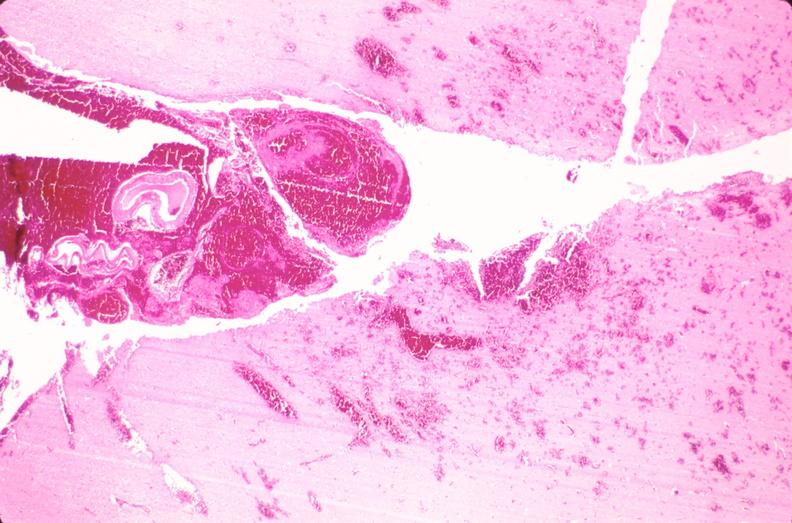what does this image show?
Answer the question using a single word or phrase. Brain 